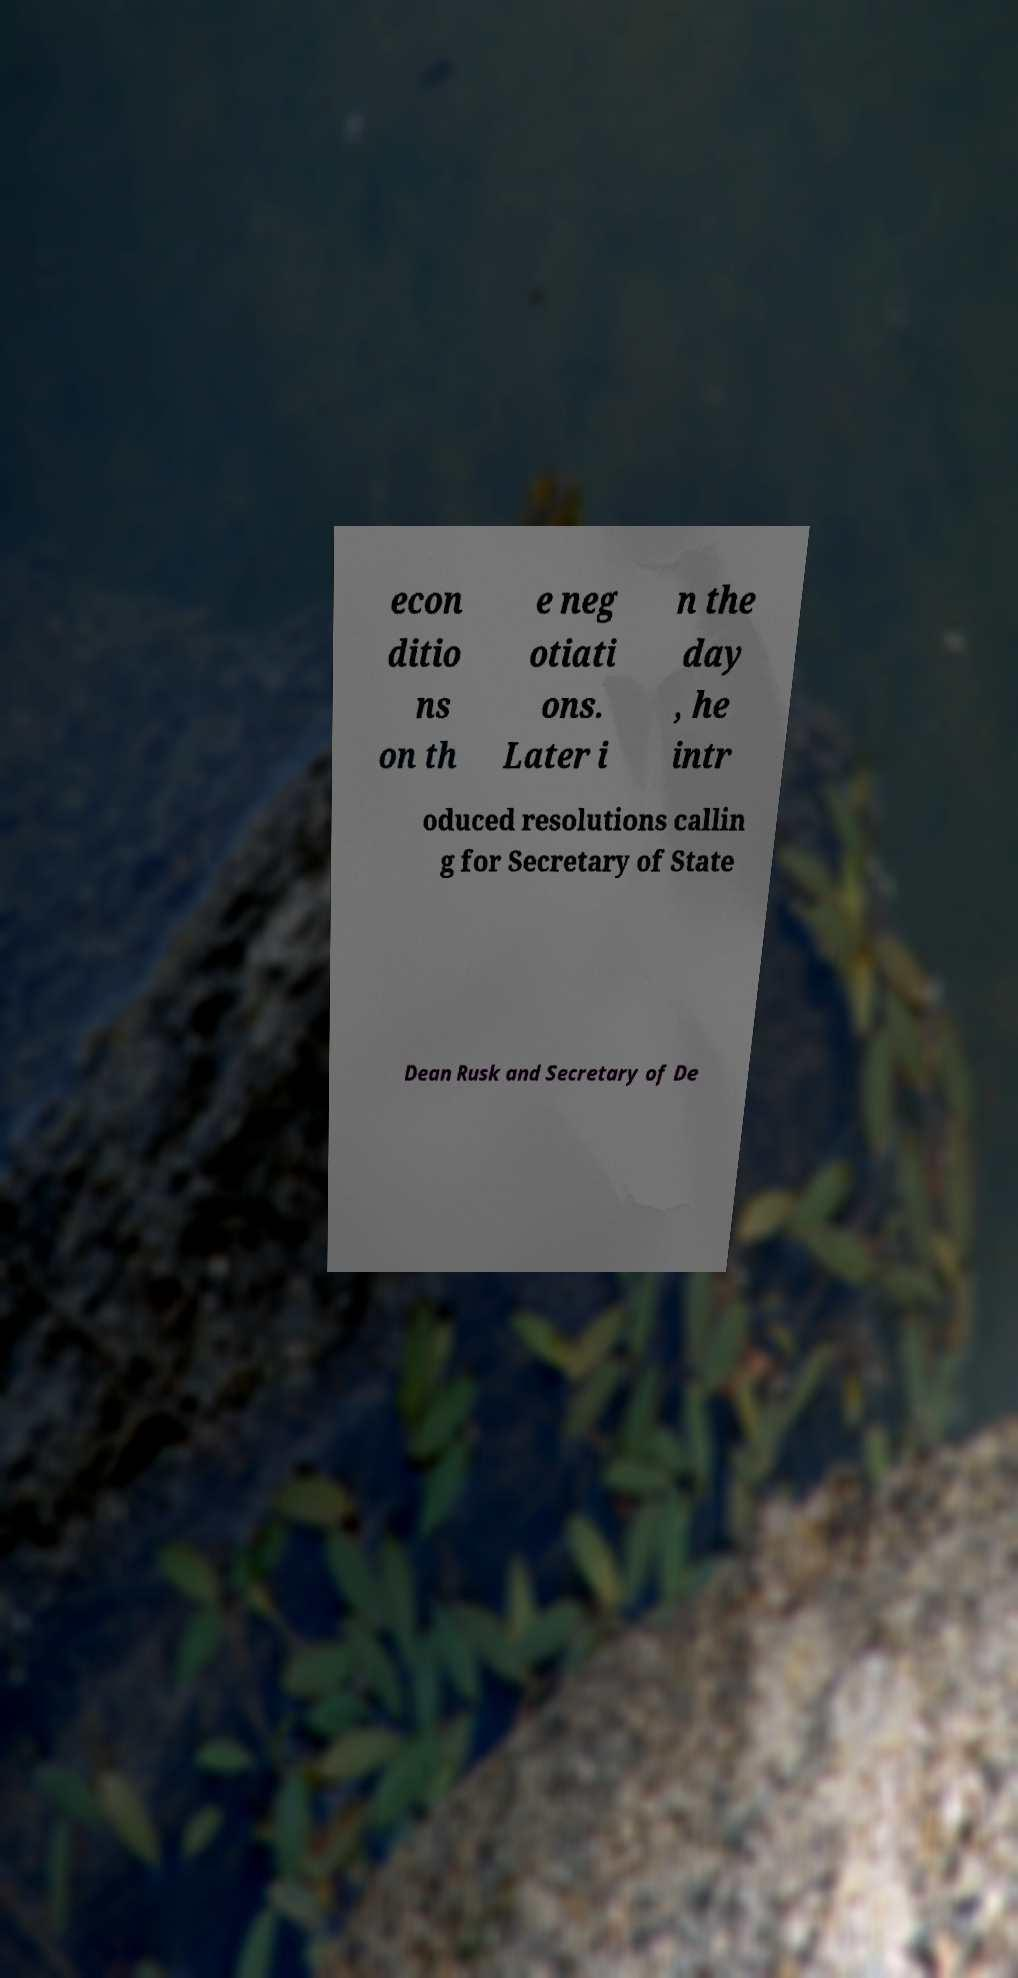For documentation purposes, I need the text within this image transcribed. Could you provide that? econ ditio ns on th e neg otiati ons. Later i n the day , he intr oduced resolutions callin g for Secretary of State Dean Rusk and Secretary of De 